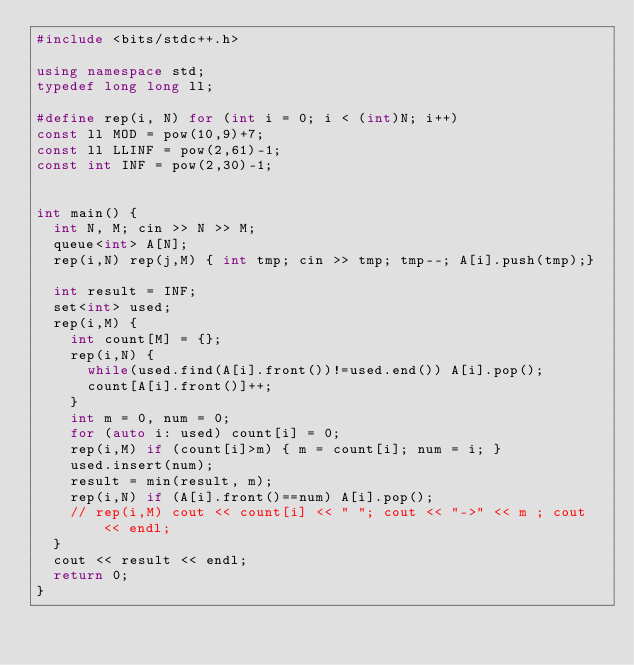<code> <loc_0><loc_0><loc_500><loc_500><_C++_>#include <bits/stdc++.h>

using namespace std;
typedef long long ll;

#define rep(i, N) for (int i = 0; i < (int)N; i++)
const ll MOD = pow(10,9)+7;
const ll LLINF = pow(2,61)-1;
const int INF = pow(2,30)-1;


int main() {
  int N, M; cin >> N >> M;
  queue<int> A[N];
  rep(i,N) rep(j,M) { int tmp; cin >> tmp; tmp--; A[i].push(tmp);}

  int result = INF;
  set<int> used;
  rep(i,M) {
    int count[M] = {};
    rep(i,N) {
      while(used.find(A[i].front())!=used.end()) A[i].pop();
      count[A[i].front()]++;
    }
    int m = 0, num = 0;
    for (auto i: used) count[i] = 0;
    rep(i,M) if (count[i]>m) { m = count[i]; num = i; }
    used.insert(num);
    result = min(result, m);
    rep(i,N) if (A[i].front()==num) A[i].pop();
    // rep(i,M) cout << count[i] << " "; cout << "->" << m ; cout << endl;
  }
  cout << result << endl;
  return 0;
}</code> 